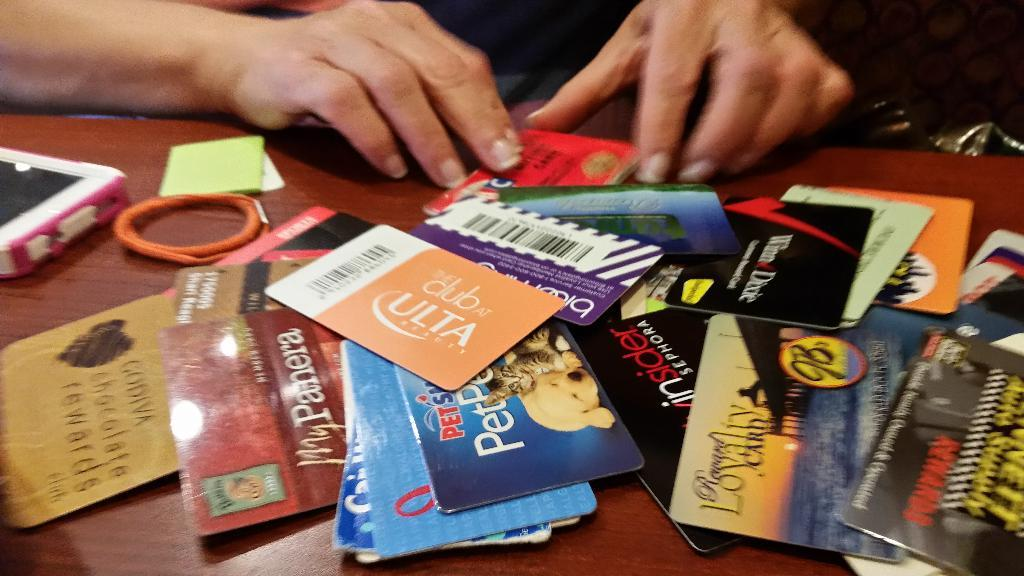<image>
Summarize the visual content of the image. A person sits at atable with a small pile of gift card from Ulta and other places. 